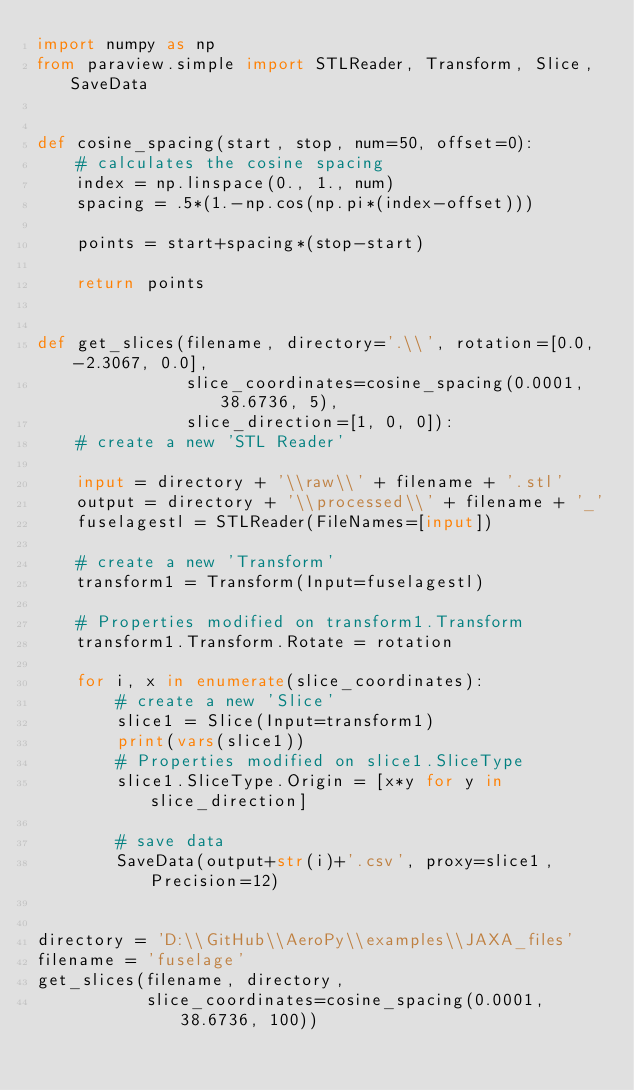Convert code to text. <code><loc_0><loc_0><loc_500><loc_500><_Python_>import numpy as np
from paraview.simple import STLReader, Transform, Slice, SaveData


def cosine_spacing(start, stop, num=50, offset=0):
    # calculates the cosine spacing
    index = np.linspace(0., 1., num)
    spacing = .5*(1.-np.cos(np.pi*(index-offset)))

    points = start+spacing*(stop-start)

    return points


def get_slices(filename, directory='.\\', rotation=[0.0, -2.3067, 0.0],
               slice_coordinates=cosine_spacing(0.0001, 38.6736, 5),
               slice_direction=[1, 0, 0]):
    # create a new 'STL Reader'

    input = directory + '\\raw\\' + filename + '.stl'
    output = directory + '\\processed\\' + filename + '_'
    fuselagestl = STLReader(FileNames=[input])

    # create a new 'Transform'
    transform1 = Transform(Input=fuselagestl)

    # Properties modified on transform1.Transform
    transform1.Transform.Rotate = rotation

    for i, x in enumerate(slice_coordinates):
        # create a new 'Slice'
        slice1 = Slice(Input=transform1)
        print(vars(slice1))
        # Properties modified on slice1.SliceType
        slice1.SliceType.Origin = [x*y for y in slice_direction]

        # save data
        SaveData(output+str(i)+'.csv', proxy=slice1, Precision=12)


directory = 'D:\\GitHub\\AeroPy\\examples\\JAXA_files'
filename = 'fuselage'
get_slices(filename, directory,
           slice_coordinates=cosine_spacing(0.0001, 38.6736, 100))
</code> 